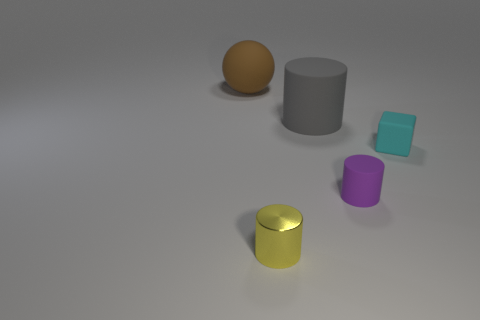What number of cylinders are green metal objects or large brown objects?
Your response must be concise. 0. Is the number of tiny yellow things that are in front of the tiny shiny cylinder less than the number of cyan blocks?
Give a very brief answer. Yes. What shape is the purple object that is made of the same material as the cyan object?
Your answer should be very brief. Cylinder. How many things are either big yellow spheres or cylinders?
Offer a terse response. 3. What material is the cylinder behind the cyan block that is behind the tiny purple matte cylinder?
Offer a very short reply. Rubber. Are there any tiny blocks that have the same material as the big gray cylinder?
Keep it short and to the point. Yes. There is a big thing in front of the large matte thing left of the large matte thing that is to the right of the rubber ball; what is its shape?
Your response must be concise. Cylinder. What is the tiny purple cylinder made of?
Provide a succinct answer. Rubber. There is a cube that is made of the same material as the large gray thing; what is its color?
Keep it short and to the point. Cyan. There is a big matte thing on the left side of the small yellow metal cylinder; is there a brown rubber thing that is in front of it?
Provide a short and direct response. No. 